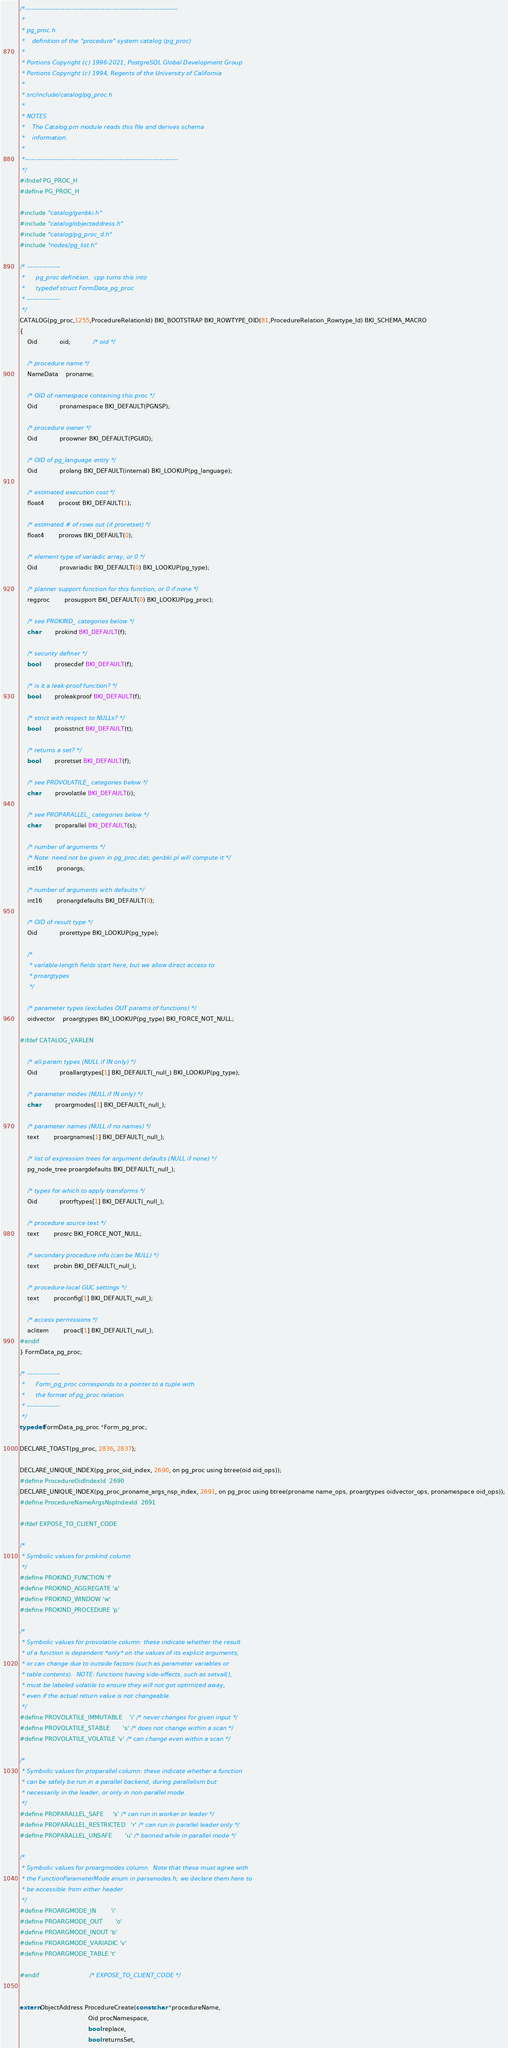Convert code to text. <code><loc_0><loc_0><loc_500><loc_500><_C_>/*-------------------------------------------------------------------------
 *
 * pg_proc.h
 *	  definition of the "procedure" system catalog (pg_proc)
 *
 * Portions Copyright (c) 1996-2021, PostgreSQL Global Development Group
 * Portions Copyright (c) 1994, Regents of the University of California
 *
 * src/include/catalog/pg_proc.h
 *
 * NOTES
 *	  The Catalog.pm module reads this file and derives schema
 *	  information.
 *
 *-------------------------------------------------------------------------
 */
#ifndef PG_PROC_H
#define PG_PROC_H

#include "catalog/genbki.h"
#include "catalog/objectaddress.h"
#include "catalog/pg_proc_d.h"
#include "nodes/pg_list.h"

/* ----------------
 *		pg_proc definition.  cpp turns this into
 *		typedef struct FormData_pg_proc
 * ----------------
 */
CATALOG(pg_proc,1255,ProcedureRelationId) BKI_BOOTSTRAP BKI_ROWTYPE_OID(81,ProcedureRelation_Rowtype_Id) BKI_SCHEMA_MACRO
{
	Oid			oid;			/* oid */

	/* procedure name */
	NameData	proname;

	/* OID of namespace containing this proc */
	Oid			pronamespace BKI_DEFAULT(PGNSP);

	/* procedure owner */
	Oid			proowner BKI_DEFAULT(PGUID);

	/* OID of pg_language entry */
	Oid			prolang BKI_DEFAULT(internal) BKI_LOOKUP(pg_language);

	/* estimated execution cost */
	float4		procost BKI_DEFAULT(1);

	/* estimated # of rows out (if proretset) */
	float4		prorows BKI_DEFAULT(0);

	/* element type of variadic array, or 0 */
	Oid			provariadic BKI_DEFAULT(0) BKI_LOOKUP(pg_type);

	/* planner support function for this function, or 0 if none */
	regproc		prosupport BKI_DEFAULT(0) BKI_LOOKUP(pg_proc);

	/* see PROKIND_ categories below */
	char		prokind BKI_DEFAULT(f);

	/* security definer */
	bool		prosecdef BKI_DEFAULT(f);

	/* is it a leak-proof function? */
	bool		proleakproof BKI_DEFAULT(f);

	/* strict with respect to NULLs? */
	bool		proisstrict BKI_DEFAULT(t);

	/* returns a set? */
	bool		proretset BKI_DEFAULT(f);

	/* see PROVOLATILE_ categories below */
	char		provolatile BKI_DEFAULT(i);

	/* see PROPARALLEL_ categories below */
	char		proparallel BKI_DEFAULT(s);

	/* number of arguments */
	/* Note: need not be given in pg_proc.dat; genbki.pl will compute it */
	int16		pronargs;

	/* number of arguments with defaults */
	int16		pronargdefaults BKI_DEFAULT(0);

	/* OID of result type */
	Oid			prorettype BKI_LOOKUP(pg_type);

	/*
	 * variable-length fields start here, but we allow direct access to
	 * proargtypes
	 */

	/* parameter types (excludes OUT params of functions) */
	oidvector	proargtypes BKI_LOOKUP(pg_type) BKI_FORCE_NOT_NULL;

#ifdef CATALOG_VARLEN

	/* all param types (NULL if IN only) */
	Oid			proallargtypes[1] BKI_DEFAULT(_null_) BKI_LOOKUP(pg_type);

	/* parameter modes (NULL if IN only) */
	char		proargmodes[1] BKI_DEFAULT(_null_);

	/* parameter names (NULL if no names) */
	text		proargnames[1] BKI_DEFAULT(_null_);

	/* list of expression trees for argument defaults (NULL if none) */
	pg_node_tree proargdefaults BKI_DEFAULT(_null_);

	/* types for which to apply transforms */
	Oid			protrftypes[1] BKI_DEFAULT(_null_);

	/* procedure source text */
	text		prosrc BKI_FORCE_NOT_NULL;

	/* secondary procedure info (can be NULL) */
	text		probin BKI_DEFAULT(_null_);

	/* procedure-local GUC settings */
	text		proconfig[1] BKI_DEFAULT(_null_);

	/* access permissions */
	aclitem		proacl[1] BKI_DEFAULT(_null_);
#endif
} FormData_pg_proc;

/* ----------------
 *		Form_pg_proc corresponds to a pointer to a tuple with
 *		the format of pg_proc relation.
 * ----------------
 */
typedef FormData_pg_proc *Form_pg_proc;

DECLARE_TOAST(pg_proc, 2836, 2837);

DECLARE_UNIQUE_INDEX(pg_proc_oid_index, 2690, on pg_proc using btree(oid oid_ops));
#define ProcedureOidIndexId  2690
DECLARE_UNIQUE_INDEX(pg_proc_proname_args_nsp_index, 2691, on pg_proc using btree(proname name_ops, proargtypes oidvector_ops, pronamespace oid_ops));
#define ProcedureNameArgsNspIndexId  2691

#ifdef EXPOSE_TO_CLIENT_CODE

/*
 * Symbolic values for prokind column
 */
#define PROKIND_FUNCTION 'f'
#define PROKIND_AGGREGATE 'a'
#define PROKIND_WINDOW 'w'
#define PROKIND_PROCEDURE 'p'

/*
 * Symbolic values for provolatile column: these indicate whether the result
 * of a function is dependent *only* on the values of its explicit arguments,
 * or can change due to outside factors (such as parameter variables or
 * table contents).  NOTE: functions having side-effects, such as setval(),
 * must be labeled volatile to ensure they will not get optimized away,
 * even if the actual return value is not changeable.
 */
#define PROVOLATILE_IMMUTABLE	'i' /* never changes for given input */
#define PROVOLATILE_STABLE		's' /* does not change within a scan */
#define PROVOLATILE_VOLATILE	'v' /* can change even within a scan */

/*
 * Symbolic values for proparallel column: these indicate whether a function
 * can be safely be run in a parallel backend, during parallelism but
 * necessarily in the leader, or only in non-parallel mode.
 */
#define PROPARALLEL_SAFE		's' /* can run in worker or leader */
#define PROPARALLEL_RESTRICTED	'r' /* can run in parallel leader only */
#define PROPARALLEL_UNSAFE		'u' /* banned while in parallel mode */

/*
 * Symbolic values for proargmodes column.  Note that these must agree with
 * the FunctionParameterMode enum in parsenodes.h; we declare them here to
 * be accessible from either header.
 */
#define PROARGMODE_IN		'i'
#define PROARGMODE_OUT		'o'
#define PROARGMODE_INOUT	'b'
#define PROARGMODE_VARIADIC 'v'
#define PROARGMODE_TABLE	't'

#endif							/* EXPOSE_TO_CLIENT_CODE */


extern ObjectAddress ProcedureCreate(const char *procedureName,
									 Oid procNamespace,
									 bool replace,
									 bool returnsSet,</code> 